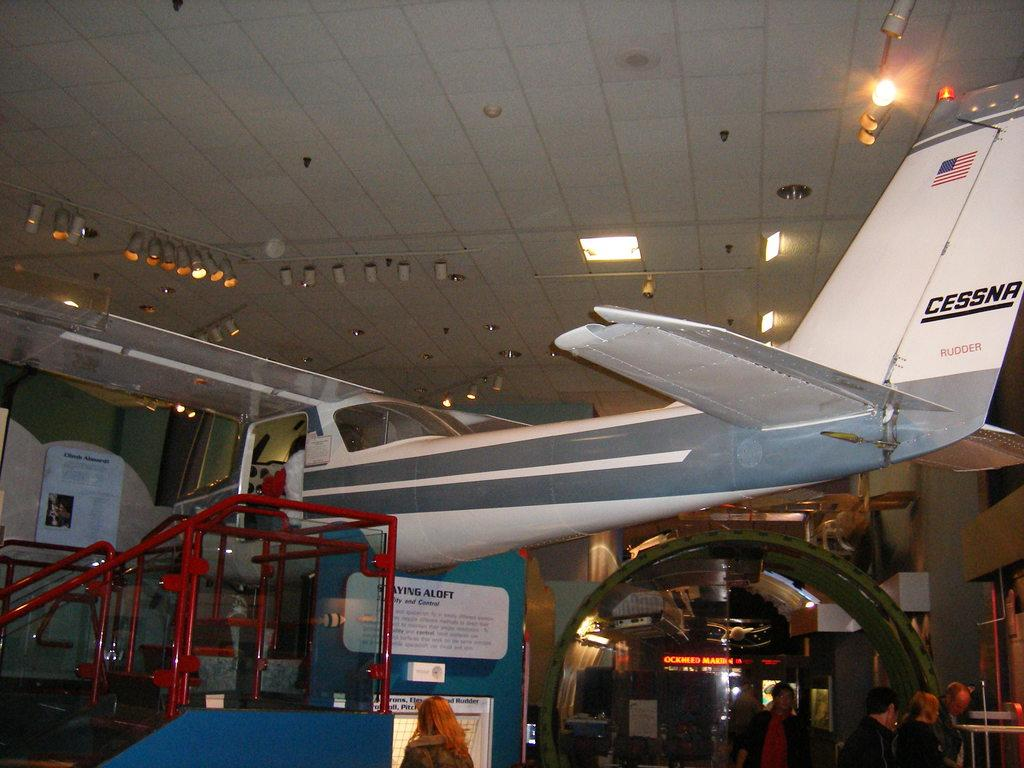<image>
Summarize the visual content of the image. A white Cessna Rudder plane inside a museum on display. 